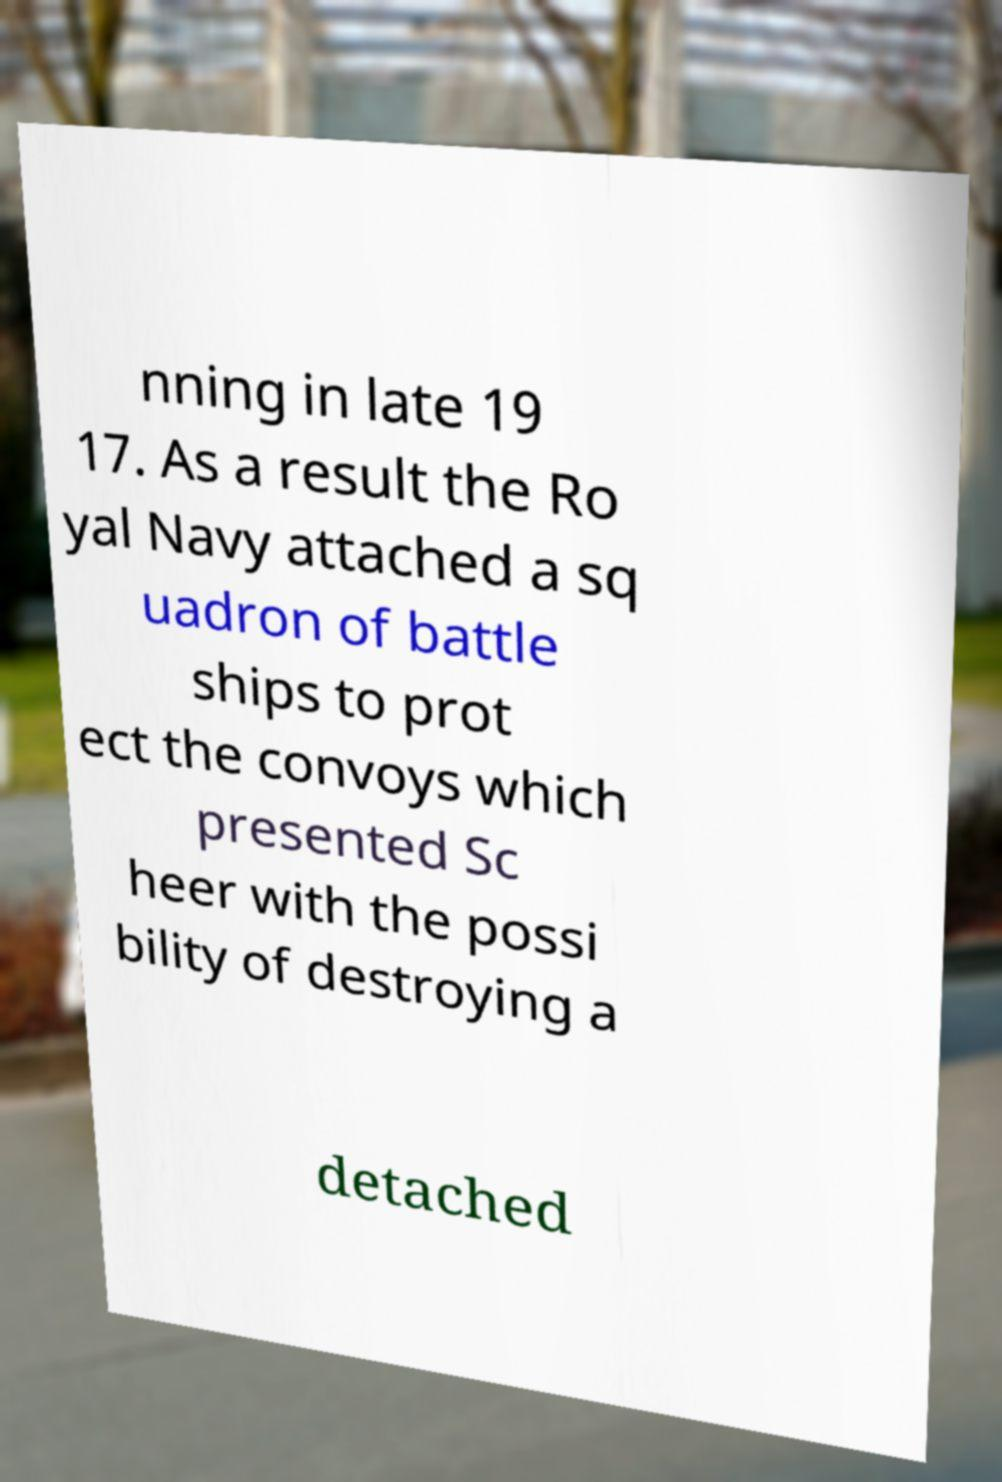Could you extract and type out the text from this image? nning in late 19 17. As a result the Ro yal Navy attached a sq uadron of battle ships to prot ect the convoys which presented Sc heer with the possi bility of destroying a detached 